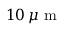Convert formula to latex. <formula><loc_0><loc_0><loc_500><loc_500>1 0 \, \mu m</formula> 